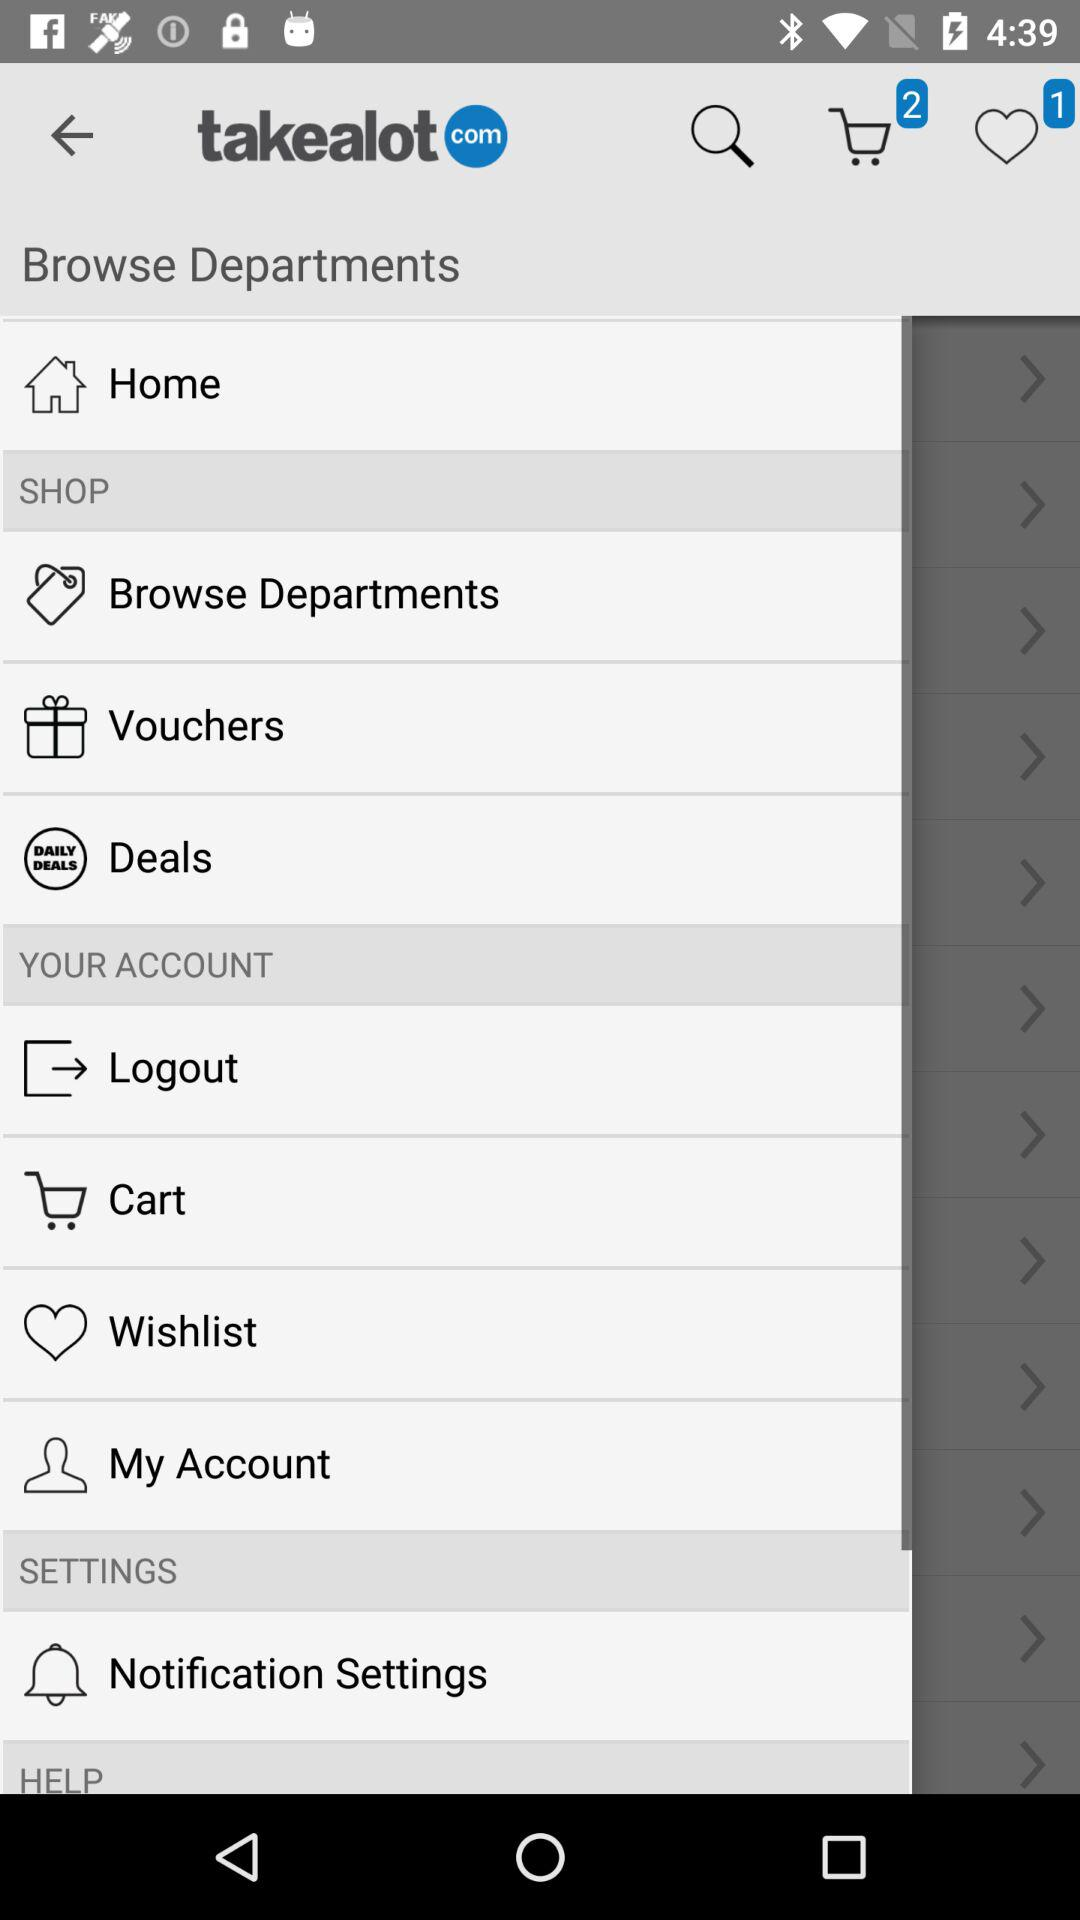How many items are in the cart?
Answer the question using a single word or phrase. 2 